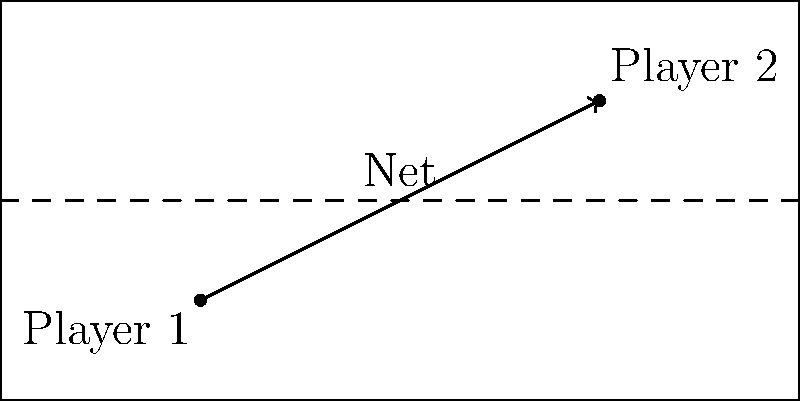In a tennis match, Player 1 is positioned at (20,10) and Player 2 is at (60,30) on a standard tennis court. The court dimensions are 80 feet long and 40 feet wide. What is the optimal angle (in degrees) for Player 1 to hit a cross-court shot to reach Player 2, measured from the baseline? To find the optimal angle for the cross-court shot, we need to follow these steps:

1) First, let's establish a coordinate system. We'll use the bottom-left corner of the court as the origin (0,0).

2) Given:
   - Player 1 position: (20,10)
   - Player 2 position: (60,30)
   - Court dimensions: 80 feet long, 40 feet wide

3) To find the angle, we need to calculate the difference in x and y coordinates between the two players:
   $\Delta x = 60 - 20 = 40$ feet
   $\Delta y = 30 - 10 = 20$ feet

4) Now we can use the arctangent function to find the angle:
   $\theta = \arctan(\frac{\Delta y}{\Delta x})$

5) Plugging in our values:
   $\theta = \arctan(\frac{20}{40})$

6) Simplify:
   $\theta = \arctan(0.5)$

7) Calculate:
   $\theta \approx 26.57°$

8) However, this angle is measured from the x-axis (baseline). To get the angle from the baseline, we need to subtract this from 90°:
   $90° - 26.57° \approx 63.43°$

Therefore, the optimal angle for Player 1 to hit a cross-court shot to reach Player 2, measured from the baseline, is approximately 63.43°.
Answer: $63.43°$ 